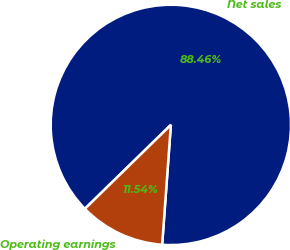Convert chart to OTSL. <chart><loc_0><loc_0><loc_500><loc_500><pie_chart><fcel>Net sales<fcel>Operating earnings<nl><fcel>88.46%<fcel>11.54%<nl></chart> 